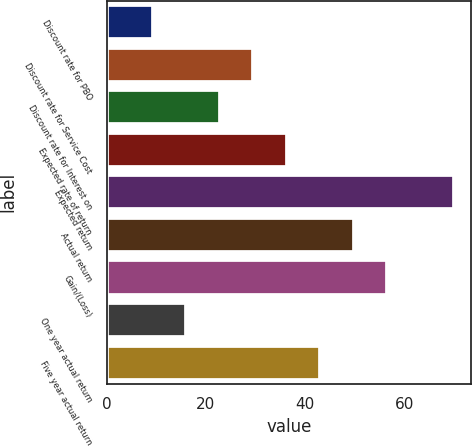Convert chart. <chart><loc_0><loc_0><loc_500><loc_500><bar_chart><fcel>Discount rate for PBO<fcel>Discount rate for Service Cost<fcel>Discount rate for Interest on<fcel>Expected rate of return<fcel>Expected return<fcel>Actual return<fcel>Gain/(Loss)<fcel>One year actual return<fcel>Five year actual return<nl><fcel>9.34<fcel>29.56<fcel>22.82<fcel>36.3<fcel>70<fcel>49.78<fcel>56.52<fcel>16.08<fcel>43.04<nl></chart> 